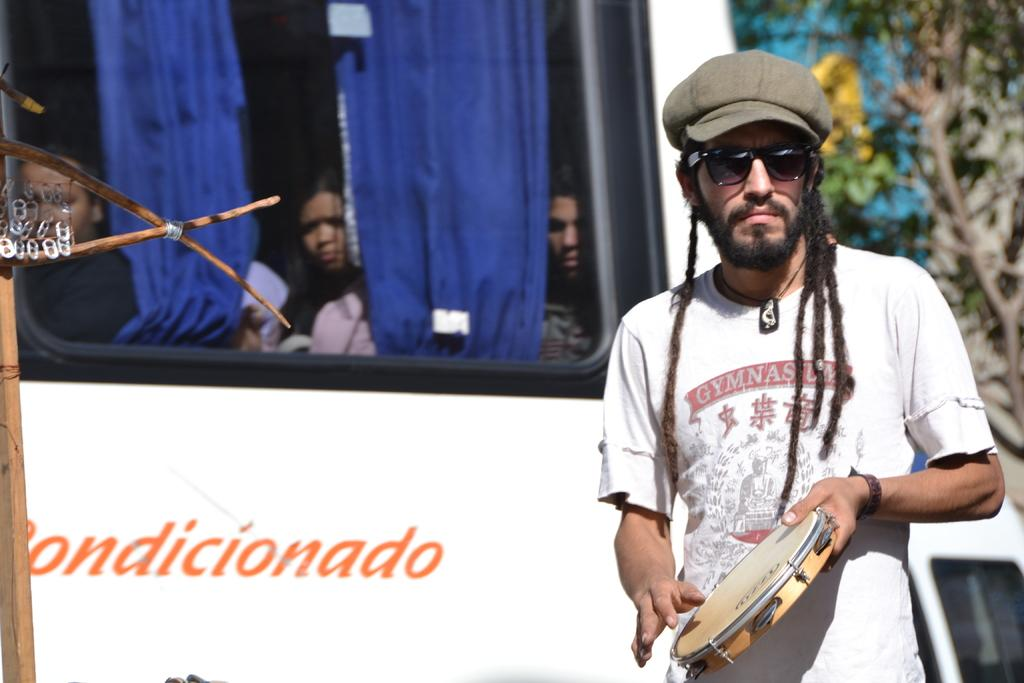What is the person on the right side of the image holding? The person is holding a musical instrument in the image. Where is the person with the musical instrument located in relation to the bus? The person is on the right side of the image, while the bus is not mentioned to be on the right side. What can be seen inside the bus in the image? There are people in a bus in the image. What type of window treatment is visible in the image? There are blue color curtains visible in the image. What type of flesh can be seen on the musical instrument in the image? There is no flesh visible on the musical instrument in the image. What time of day is depicted in the image? The provided facts do not give any information about the time of day depicted in the image. 